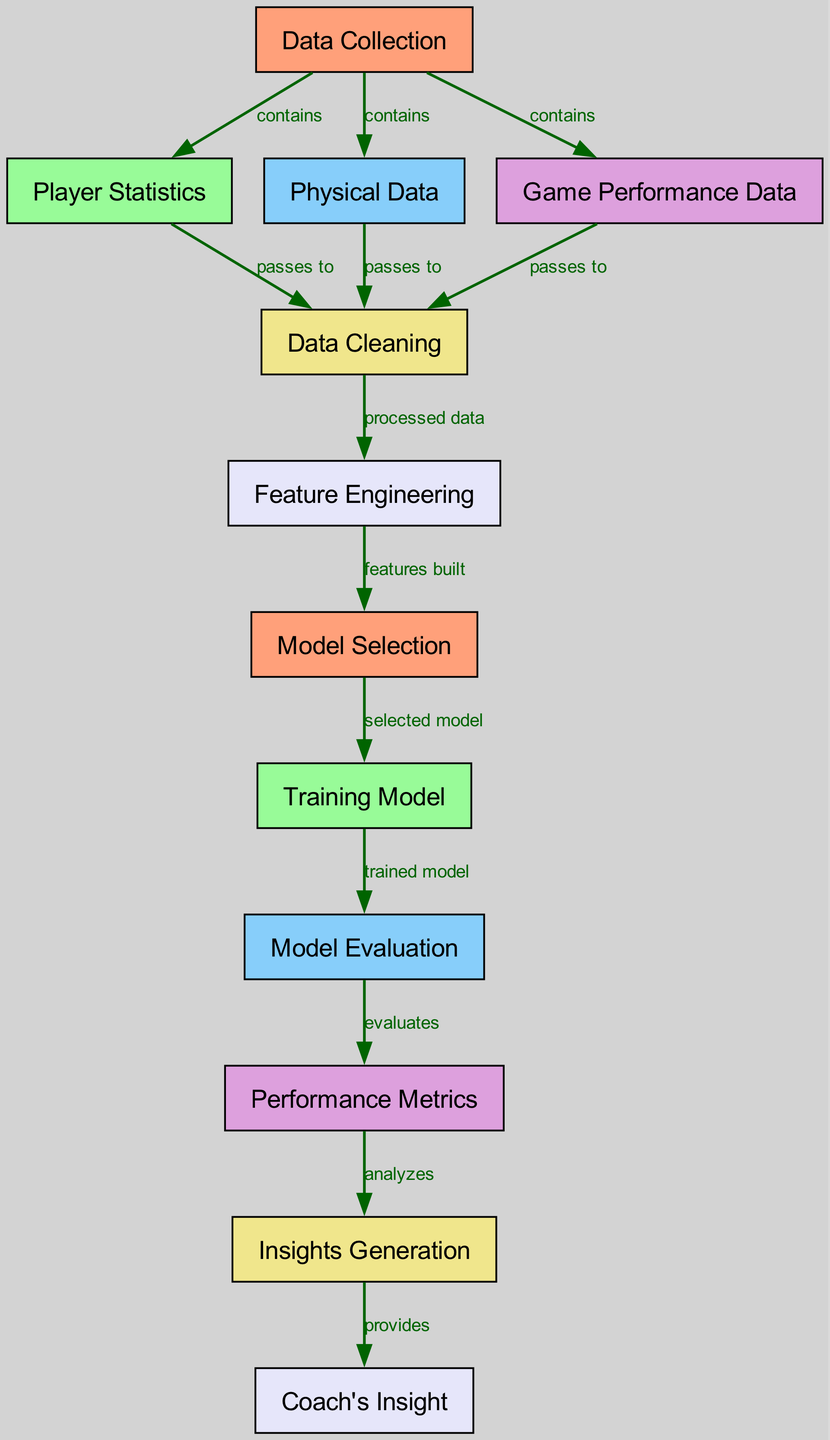What are the three types of data collected? The diagram lists three types of data under the "Data Collection" node, which are "Player Statistics," "Physical Data," and "Game Performance Data."
Answer: Player Statistics, Physical Data, Game Performance Data How many nodes are in the diagram? The diagram contains a total of 12 nodes, each representing a different step or component in the process of player performance analysis.
Answer: 12 What does "Game Performance Data" pass to? The "Game Performance Data" node is connected to the "Data Cleaning" node with a directed edge, indicating it passes its information to that node for further processing.
Answer: Data Cleaning What is the final output of this diagram called? The final output of the flow in the diagram is represented by the "Coach's Insight" node, which extracts valuable advice from the data processed earlier.
Answer: Coach's Insight What process happens after "Feature Engineering"? Following the "Feature Engineering" node, the process directs towards "Model Selection," indicating that features built there will be used to select a specific model.
Answer: Model Selection Which node evaluates the performance metrics? The "Model Evaluation" node is responsible for evaluating performance metrics based on the trained model created in the previous step of the flow.
Answer: Model Evaluation How many edges are present in the diagram? The diagram includes 11 edges, each representing the relationships and flow between the different nodes throughout the player performance analysis process.
Answer: 11 What are the sources for feature engineering? The "Data Cleaning" node serves as the source of processed data that feeds into "Feature Engineering," indicating that it utilizes cleaned data to create features.
Answer: Data Cleaning What does "Performance Metrics" analyze? The "Performance Metrics" node analyzes the data received from the "Model Evaluation" node, which measures the effectiveness of the selected model in terms of various performance indicators.
Answer: Insights Generation 